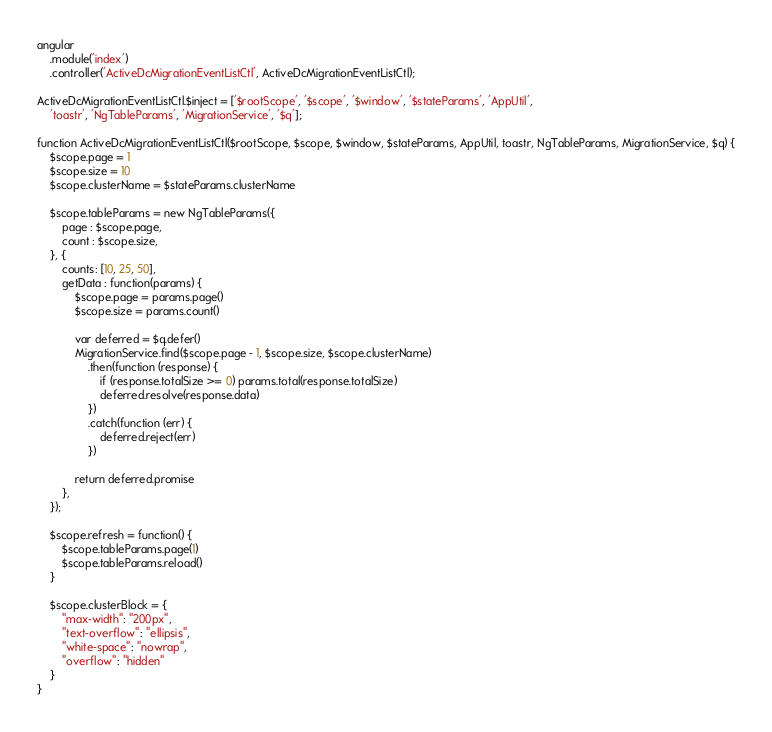Convert code to text. <code><loc_0><loc_0><loc_500><loc_500><_TypeScript_>angular
    .module('index')
    .controller('ActiveDcMigrationEventListCtl', ActiveDcMigrationEventListCtl);

ActiveDcMigrationEventListCtl.$inject = ['$rootScope', '$scope', '$window', '$stateParams', 'AppUtil',
    'toastr', 'NgTableParams', 'MigrationService', '$q'];

function ActiveDcMigrationEventListCtl($rootScope, $scope, $window, $stateParams, AppUtil, toastr, NgTableParams, MigrationService, $q) {
    $scope.page = 1
    $scope.size = 10
    $scope.clusterName = $stateParams.clusterName

	$scope.tableParams = new NgTableParams({
        page : $scope.page,
        count : $scope.size,
    }, {
        counts: [10, 25, 50],
        getData : function(params) {
            $scope.page = params.page()
            $scope.size = params.count()

            var deferred = $q.defer()
            MigrationService.find($scope.page - 1, $scope.size, $scope.clusterName)
                .then(function (response) {
                    if (response.totalSize >= 0) params.total(response.totalSize)
                    deferred.resolve(response.data)
                })
                .catch(function (err) {
                    deferred.reject(err)
                })

            return deferred.promise
        },
    });

    $scope.refresh = function() {
        $scope.tableParams.page(1)
        $scope.tableParams.reload()
    }

    $scope.clusterBlock = {
        "max-width": "200px",
        "text-overflow": "ellipsis",
        "white-space": "nowrap",
        "overflow": "hidden"
    }
}</code> 